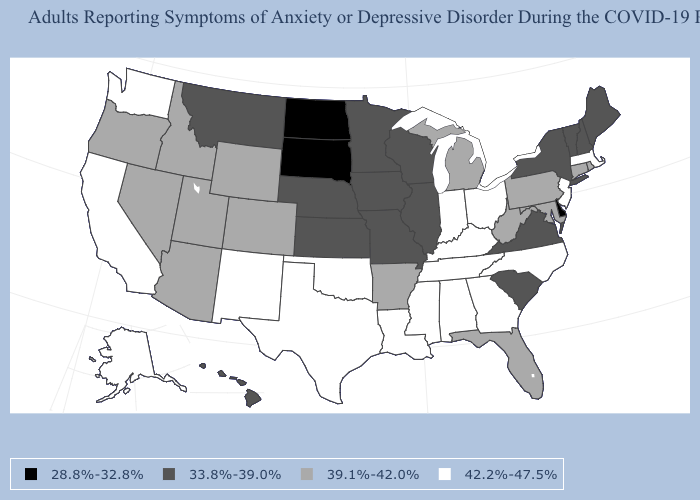What is the value of West Virginia?
Answer briefly. 39.1%-42.0%. Among the states that border Missouri , which have the lowest value?
Concise answer only. Illinois, Iowa, Kansas, Nebraska. What is the value of Massachusetts?
Keep it brief. 42.2%-47.5%. What is the value of Indiana?
Quick response, please. 42.2%-47.5%. What is the value of Massachusetts?
Short answer required. 42.2%-47.5%. What is the value of Indiana?
Answer briefly. 42.2%-47.5%. Name the states that have a value in the range 39.1%-42.0%?
Be succinct. Arizona, Arkansas, Colorado, Connecticut, Florida, Idaho, Maryland, Michigan, Nevada, Oregon, Pennsylvania, Rhode Island, Utah, West Virginia, Wyoming. Does the first symbol in the legend represent the smallest category?
Short answer required. Yes. How many symbols are there in the legend?
Write a very short answer. 4. What is the value of Wisconsin?
Be succinct. 33.8%-39.0%. Does Kentucky have the same value as Iowa?
Be succinct. No. Is the legend a continuous bar?
Give a very brief answer. No. Does New Hampshire have the same value as Vermont?
Answer briefly. Yes. What is the lowest value in the MidWest?
Be succinct. 28.8%-32.8%. Name the states that have a value in the range 39.1%-42.0%?
Give a very brief answer. Arizona, Arkansas, Colorado, Connecticut, Florida, Idaho, Maryland, Michigan, Nevada, Oregon, Pennsylvania, Rhode Island, Utah, West Virginia, Wyoming. 